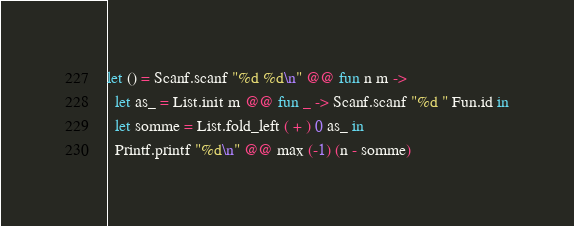Convert code to text. <code><loc_0><loc_0><loc_500><loc_500><_OCaml_>let () = Scanf.scanf "%d %d\n" @@ fun n m ->
  let as_ = List.init m @@ fun _ -> Scanf.scanf "%d " Fun.id in
  let somme = List.fold_left ( + ) 0 as_ in
  Printf.printf "%d\n" @@ max (-1) (n - somme)
</code> 